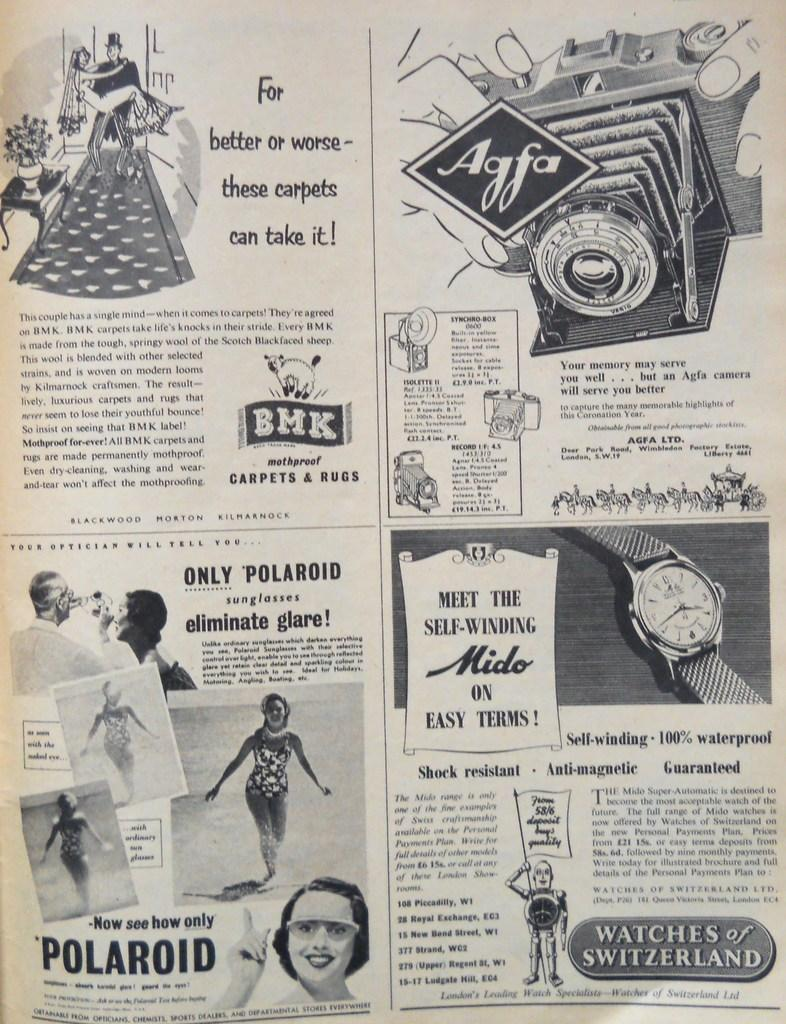<image>
Provide a brief description of the given image. an antique newspaper advertising sheet featuring Polaroid, and Agfa cameras 